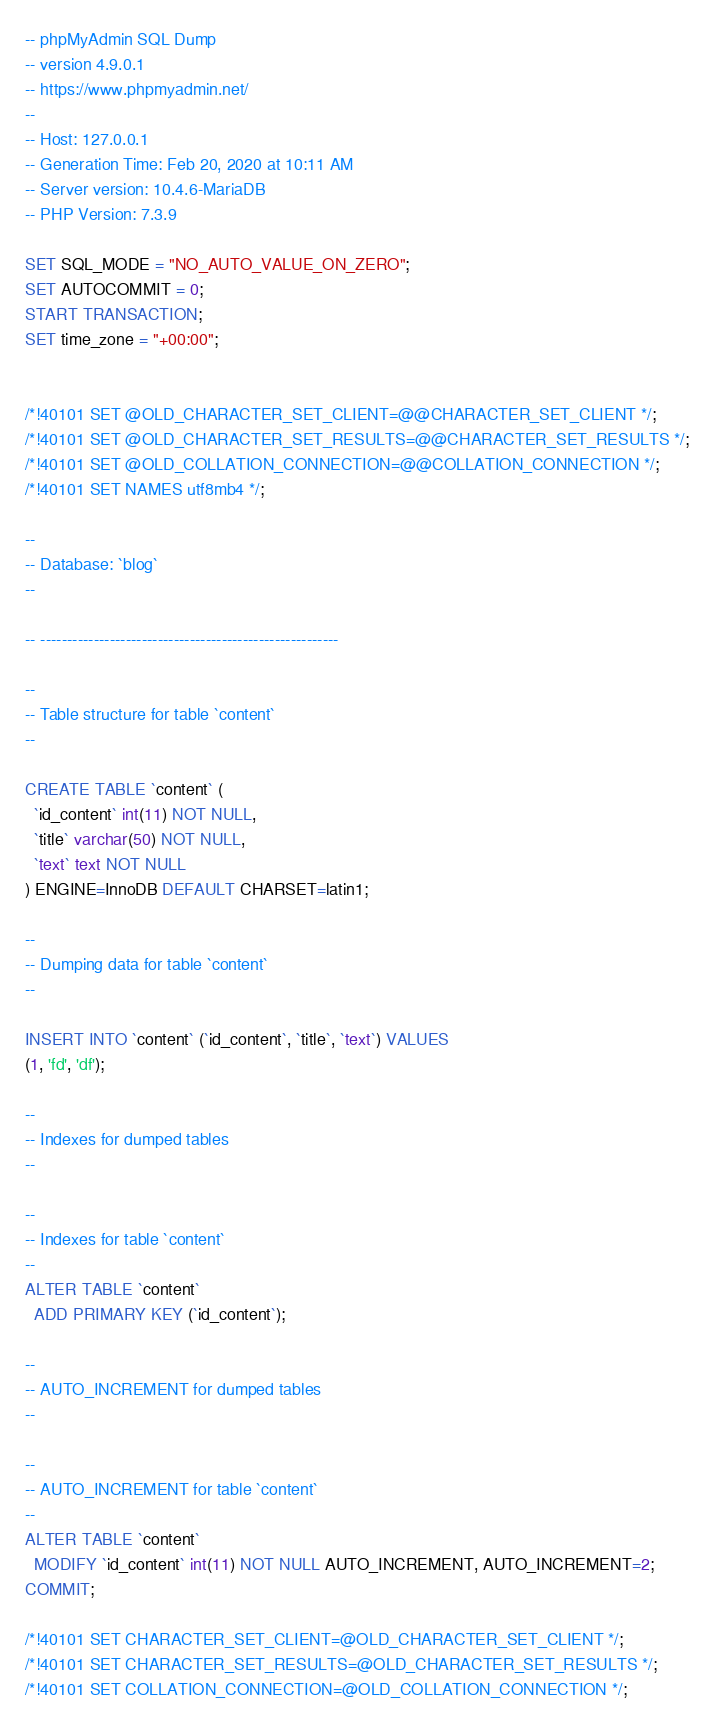Convert code to text. <code><loc_0><loc_0><loc_500><loc_500><_SQL_>-- phpMyAdmin SQL Dump
-- version 4.9.0.1
-- https://www.phpmyadmin.net/
--
-- Host: 127.0.0.1
-- Generation Time: Feb 20, 2020 at 10:11 AM
-- Server version: 10.4.6-MariaDB
-- PHP Version: 7.3.9

SET SQL_MODE = "NO_AUTO_VALUE_ON_ZERO";
SET AUTOCOMMIT = 0;
START TRANSACTION;
SET time_zone = "+00:00";


/*!40101 SET @OLD_CHARACTER_SET_CLIENT=@@CHARACTER_SET_CLIENT */;
/*!40101 SET @OLD_CHARACTER_SET_RESULTS=@@CHARACTER_SET_RESULTS */;
/*!40101 SET @OLD_COLLATION_CONNECTION=@@COLLATION_CONNECTION */;
/*!40101 SET NAMES utf8mb4 */;

--
-- Database: `blog`
--

-- --------------------------------------------------------

--
-- Table structure for table `content`
--

CREATE TABLE `content` (
  `id_content` int(11) NOT NULL,
  `title` varchar(50) NOT NULL,
  `text` text NOT NULL
) ENGINE=InnoDB DEFAULT CHARSET=latin1;

--
-- Dumping data for table `content`
--

INSERT INTO `content` (`id_content`, `title`, `text`) VALUES
(1, 'fd', 'df');

--
-- Indexes for dumped tables
--

--
-- Indexes for table `content`
--
ALTER TABLE `content`
  ADD PRIMARY KEY (`id_content`);

--
-- AUTO_INCREMENT for dumped tables
--

--
-- AUTO_INCREMENT for table `content`
--
ALTER TABLE `content`
  MODIFY `id_content` int(11) NOT NULL AUTO_INCREMENT, AUTO_INCREMENT=2;
COMMIT;

/*!40101 SET CHARACTER_SET_CLIENT=@OLD_CHARACTER_SET_CLIENT */;
/*!40101 SET CHARACTER_SET_RESULTS=@OLD_CHARACTER_SET_RESULTS */;
/*!40101 SET COLLATION_CONNECTION=@OLD_COLLATION_CONNECTION */;
</code> 